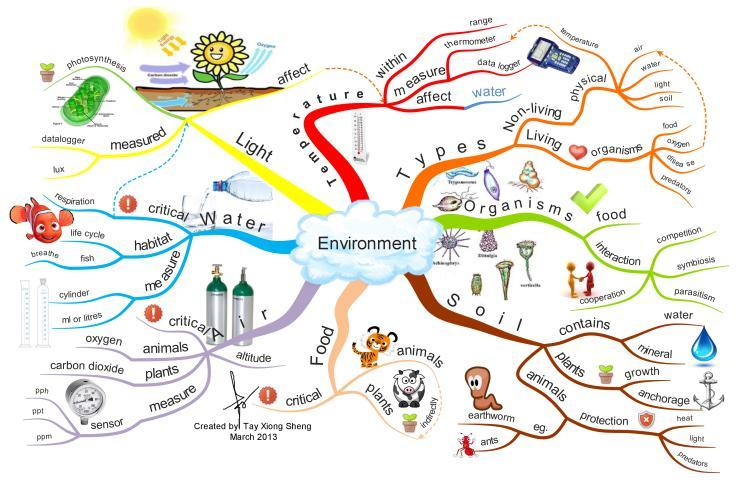What do animals get from air that plants give off?
Answer the question with a short phrase. oxygen What is the unit of light? lux What are the two types of environment? Non-living physical, Living organisms Which device is used to measure the temperature? thermometer What does soil contain? water, mineral 